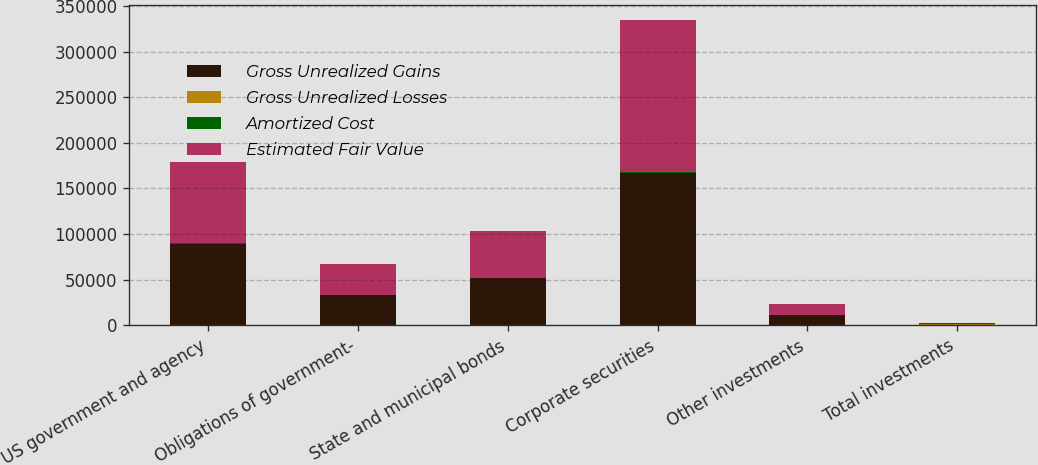<chart> <loc_0><loc_0><loc_500><loc_500><stacked_bar_chart><ecel><fcel>US government and agency<fcel>Obligations of government-<fcel>State and municipal bonds<fcel>Corporate securities<fcel>Other investments<fcel>Total investments<nl><fcel>Gross Unrealized Gains<fcel>89617<fcel>33506<fcel>51573<fcel>166642<fcel>11771<fcel>699<nl><fcel>Gross Unrealized Losses<fcel>27<fcel>5<fcel>82<fcel>453<fcel>15<fcel>582<nl><fcel>Amortized Cost<fcel>18<fcel>1<fcel>28<fcel>675<fcel>1<fcel>723<nl><fcel>Estimated Fair Value<fcel>89626<fcel>33510<fcel>51627<fcel>166420<fcel>11785<fcel>699<nl></chart> 